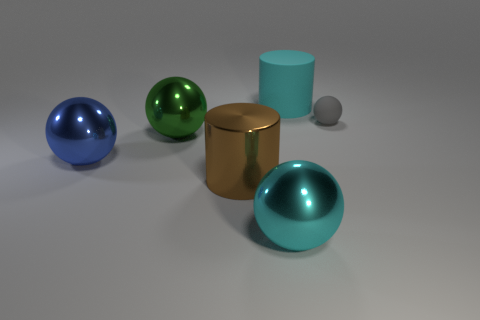There is another large thing that is the same shape as the brown object; what is its color?
Offer a very short reply. Cyan. There is a metallic sphere that is the same color as the matte cylinder; what is its size?
Ensure brevity in your answer.  Large. How many other things are there of the same size as the matte cylinder?
Ensure brevity in your answer.  4. Are the cylinder in front of the large cyan matte cylinder and the big blue ball made of the same material?
Ensure brevity in your answer.  Yes. What number of other things are the same color as the rubber ball?
Offer a terse response. 0. How many other objects are the same shape as the gray matte object?
Offer a very short reply. 3. Does the matte object that is in front of the cyan matte thing have the same shape as the cyan object that is behind the large brown metallic cylinder?
Your response must be concise. No. Is the number of blue balls behind the cyan matte cylinder the same as the number of big green balls behind the metallic cylinder?
Provide a succinct answer. No. There is a cyan object behind the metallic ball that is right of the large cylinder that is on the left side of the large matte cylinder; what shape is it?
Provide a short and direct response. Cylinder. Do the large thing in front of the brown cylinder and the thing that is on the right side of the large cyan cylinder have the same material?
Your answer should be compact. No. 